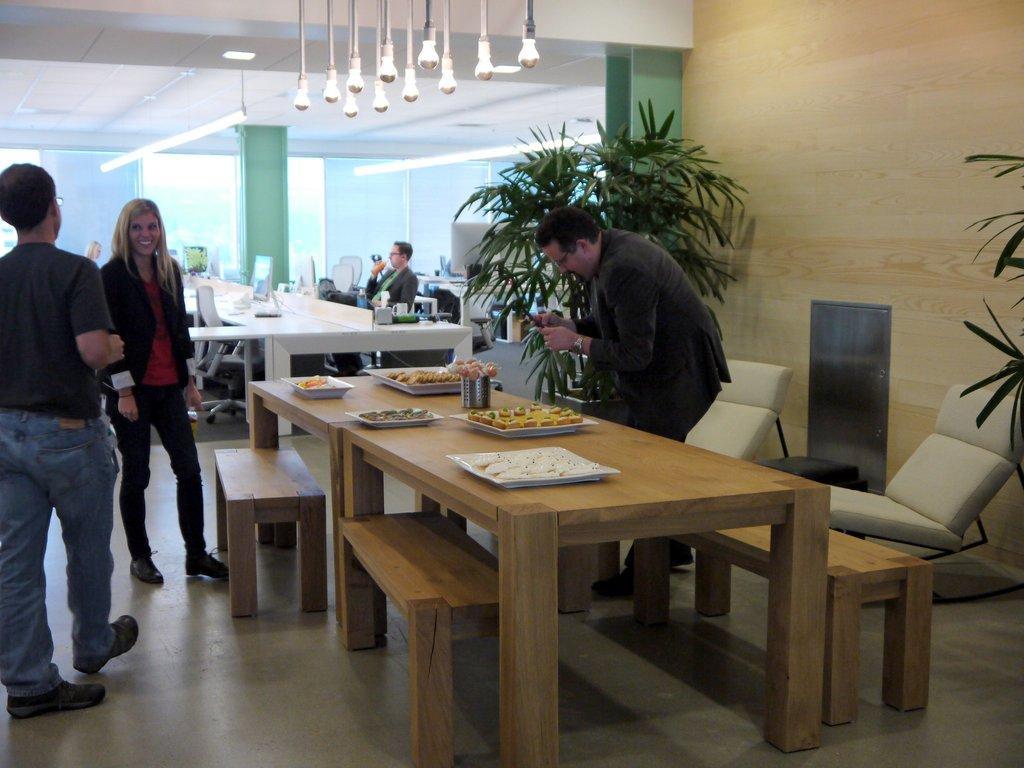Can you describe this image briefly? There are four persons. The three persons are standing and one person is sitting on a chair. He is holding a mobile. On the right side of the person is holding a mobile he is wearing a spectacle. There is a table. There is a glass,tray,plate ,sweets on a table. In the center there is a another table. There is a monitor and keyboard ,mouse ,cup and name board on a table. We can see in the background wall,pillar,plant and lights. 